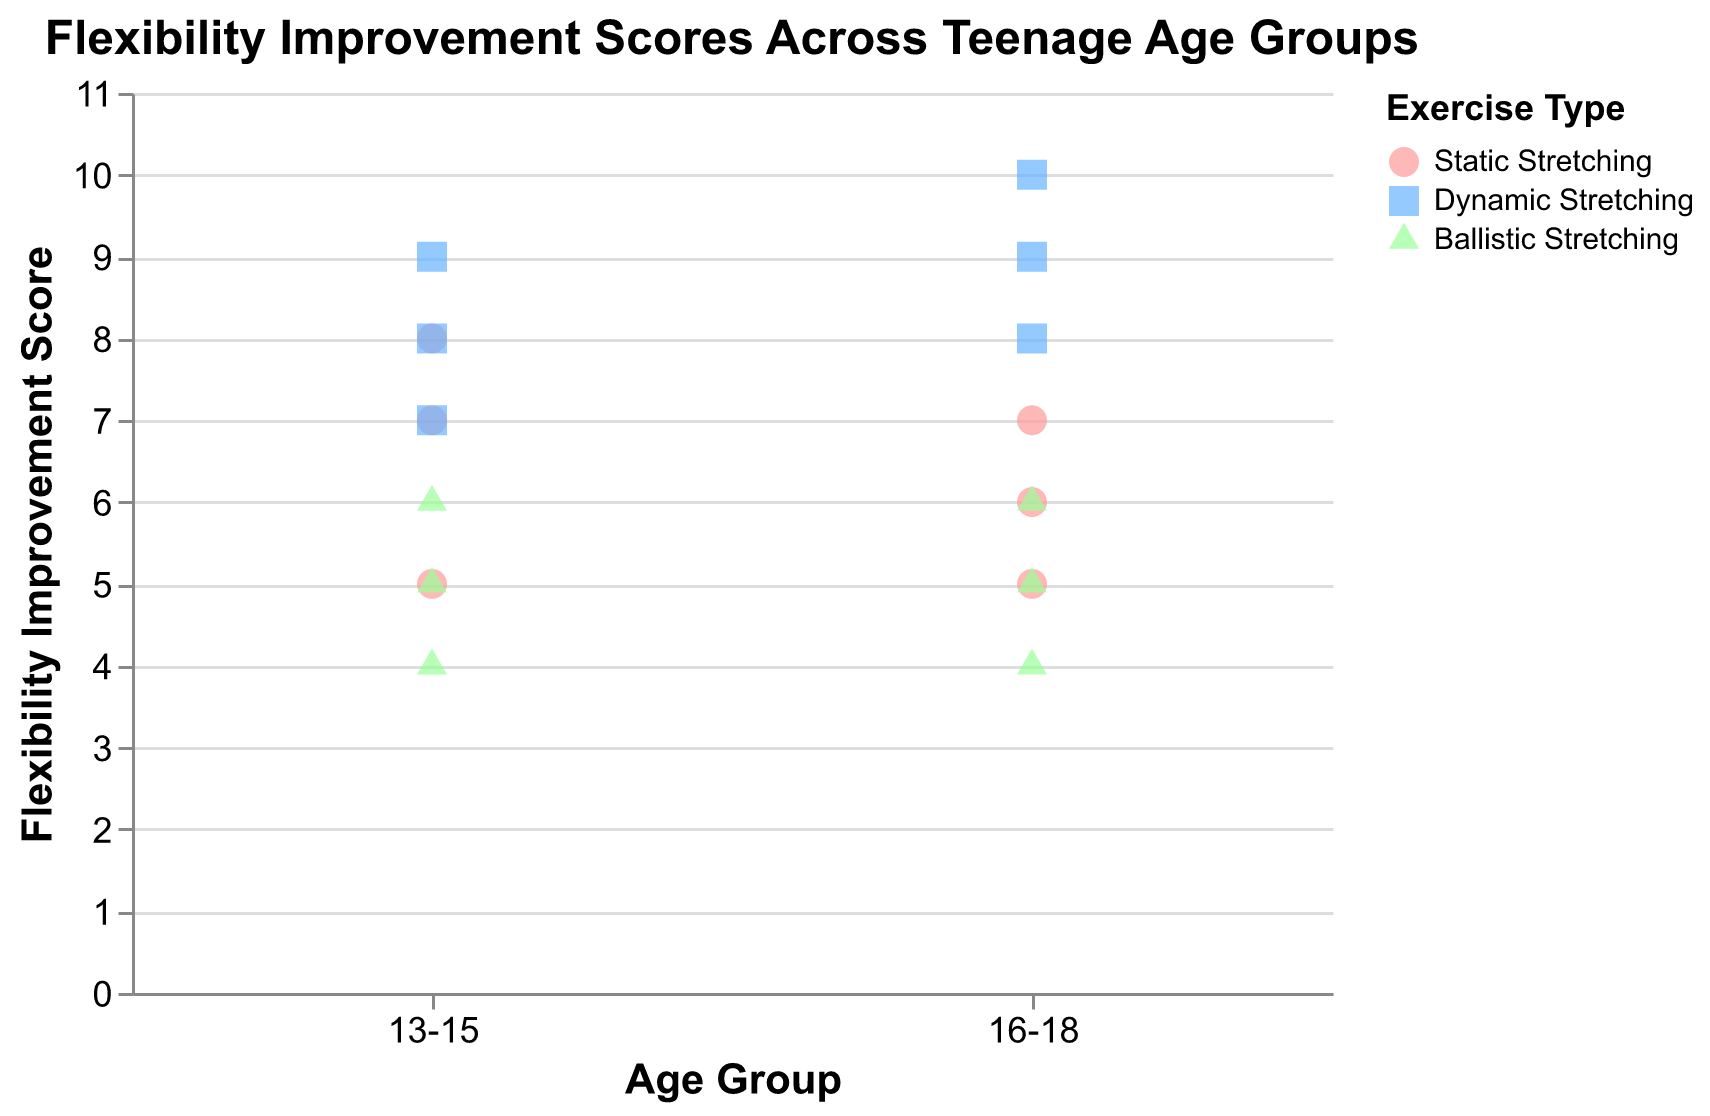What is the title of the figure? The title is usually placed at the top of the figure. In this case, it reads "Flexibility Improvement Scores Across Teenage Age Groups".
Answer: Flexibility Improvement Scores Across Teenage Age Groups How many age groups are represented in the figure? The x-axis shows distinct categories corresponding to age groups. Here, it lists "13-15" and "16-18".
Answer: 2 Which type of exercise has the highest flexibility improvement score in the 16-18 age group? Look for the highest point on the y-axis labeled "16-18" and check the color and shape of the point according to the legend. The highest point (score of 10) is light blue and square, indicating Dynamic Stretching.
Answer: Dynamic Stretching What is the median flexibility improvement score for participants doing Static Stretching in the 13-15 age group? List the flexibility improvement scores for Static Stretching in the 13-15 group (7, 5, 8), then find the median value. The median is the middle value in the ordered list: 5, 7, 8.
Answer: 7 Which age group has a higher average flexibility improvement score for Dynamic Stretching? Calculate the average score for Dynamic Stretching in each age group. For 13-15: (9+7+8)/3 = 8. For 16-18: (10+8+9)/3 ≈ 9.
Answer: 16-18 How many participants are there in the 13-15 age group? Count the number of data points corresponding to the 13-15 age group on the x-axis. There are 9 data points for age group 13-15 (3 for each exercise type).
Answer: 9 Do participants in the 16-18 age group show a wider range of flexibility improvement scores than those in the 13-15 age group for Ballistic Stretching? Compare the range (difference between max and min scores) for Ballistic Stretching in each age group. For 13-15: 6 - 4 = 2. For 16-18: 6 - 4 = 2. Both groups have the same range.
Answer: No Which type of exercise has the lowest flexibility improvement score in the 13-15 age group? Look for the lowest point on the y-axis within the "13-15" category and identify its color and shape. The lowest point (score of 4) is green and triangular, indicating Ballistic Stretching.
Answer: Ballistic Stretching What is the average flexibility improvement score for all participants doing Ballistic Stretching? Sum the scores for Ballistic Stretching across all participants and divide by the number of participants. (6+4+5+5+6+4)/6 = 30/6 = 5
Answer: 5 